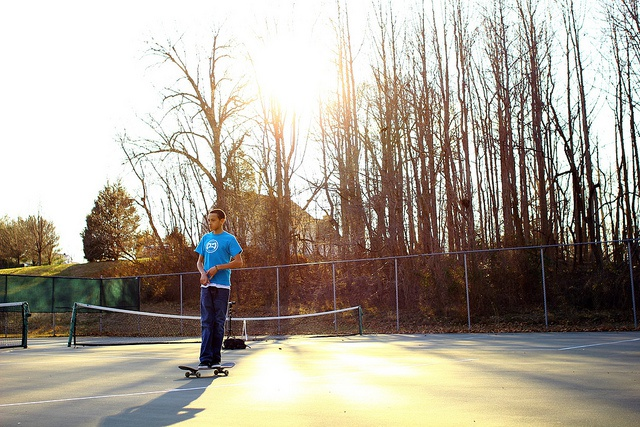Describe the objects in this image and their specific colors. I can see people in white, black, blue, navy, and gray tones and skateboard in white, black, darkgray, gray, and maroon tones in this image. 